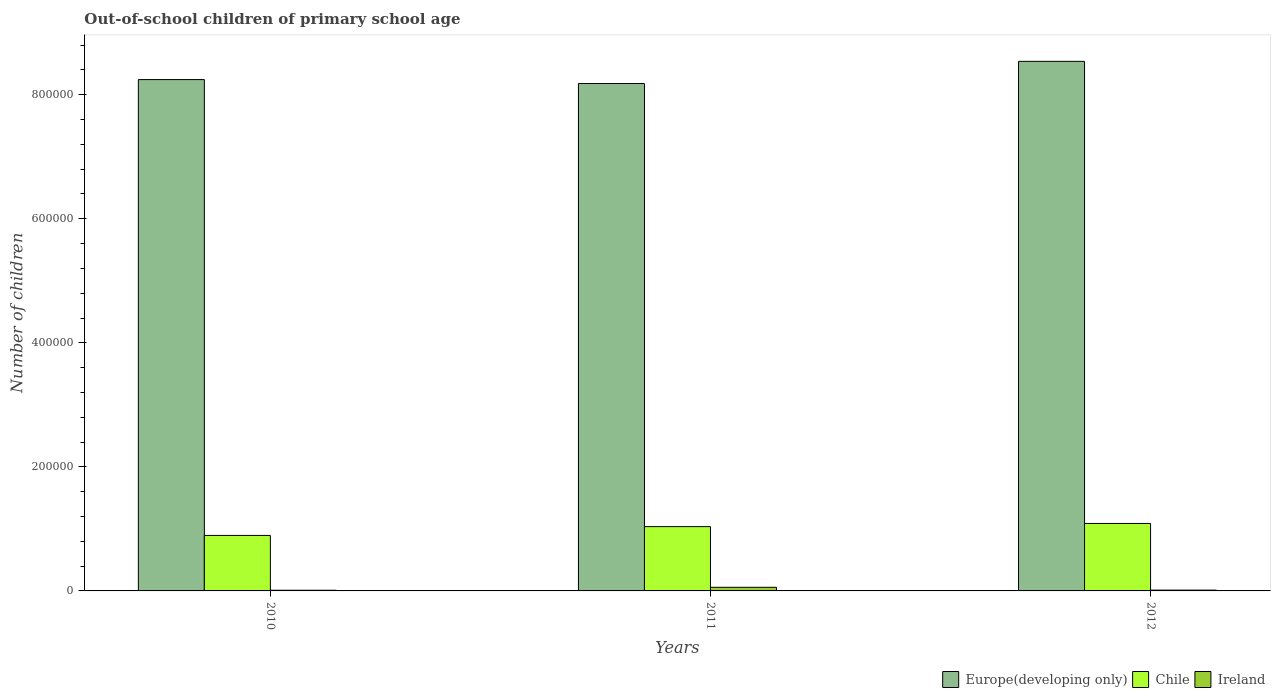How many groups of bars are there?
Make the answer very short. 3. Are the number of bars per tick equal to the number of legend labels?
Offer a very short reply. Yes. Are the number of bars on each tick of the X-axis equal?
Ensure brevity in your answer.  Yes. How many bars are there on the 3rd tick from the right?
Your answer should be compact. 3. What is the number of out-of-school children in Chile in 2012?
Provide a short and direct response. 1.09e+05. Across all years, what is the maximum number of out-of-school children in Europe(developing only)?
Give a very brief answer. 8.54e+05. Across all years, what is the minimum number of out-of-school children in Europe(developing only)?
Your answer should be compact. 8.18e+05. In which year was the number of out-of-school children in Chile maximum?
Give a very brief answer. 2012. What is the total number of out-of-school children in Ireland in the graph?
Your answer should be very brief. 8255. What is the difference between the number of out-of-school children in Chile in 2010 and that in 2011?
Make the answer very short. -1.42e+04. What is the difference between the number of out-of-school children in Chile in 2011 and the number of out-of-school children in Ireland in 2012?
Ensure brevity in your answer.  1.02e+05. What is the average number of out-of-school children in Chile per year?
Make the answer very short. 1.01e+05. In the year 2012, what is the difference between the number of out-of-school children in Europe(developing only) and number of out-of-school children in Ireland?
Give a very brief answer. 8.53e+05. What is the ratio of the number of out-of-school children in Ireland in 2011 to that in 2012?
Your response must be concise. 4.5. What is the difference between the highest and the second highest number of out-of-school children in Chile?
Your response must be concise. 5097. What is the difference between the highest and the lowest number of out-of-school children in Ireland?
Your answer should be very brief. 4752. Is the sum of the number of out-of-school children in Ireland in 2010 and 2011 greater than the maximum number of out-of-school children in Chile across all years?
Provide a short and direct response. No. What does the 1st bar from the left in 2012 represents?
Offer a very short reply. Europe(developing only). Is it the case that in every year, the sum of the number of out-of-school children in Ireland and number of out-of-school children in Europe(developing only) is greater than the number of out-of-school children in Chile?
Keep it short and to the point. Yes. How many years are there in the graph?
Keep it short and to the point. 3. What is the difference between two consecutive major ticks on the Y-axis?
Your answer should be very brief. 2.00e+05. How are the legend labels stacked?
Give a very brief answer. Horizontal. What is the title of the graph?
Your answer should be very brief. Out-of-school children of primary school age. Does "Norway" appear as one of the legend labels in the graph?
Your answer should be compact. No. What is the label or title of the Y-axis?
Your response must be concise. Number of children. What is the Number of children of Europe(developing only) in 2010?
Give a very brief answer. 8.24e+05. What is the Number of children in Chile in 2010?
Keep it short and to the point. 8.95e+04. What is the Number of children in Ireland in 2010?
Make the answer very short. 1101. What is the Number of children in Europe(developing only) in 2011?
Make the answer very short. 8.18e+05. What is the Number of children in Chile in 2011?
Your answer should be compact. 1.04e+05. What is the Number of children in Ireland in 2011?
Offer a terse response. 5853. What is the Number of children in Europe(developing only) in 2012?
Ensure brevity in your answer.  8.54e+05. What is the Number of children in Chile in 2012?
Ensure brevity in your answer.  1.09e+05. What is the Number of children in Ireland in 2012?
Ensure brevity in your answer.  1301. Across all years, what is the maximum Number of children of Europe(developing only)?
Ensure brevity in your answer.  8.54e+05. Across all years, what is the maximum Number of children of Chile?
Provide a succinct answer. 1.09e+05. Across all years, what is the maximum Number of children of Ireland?
Offer a terse response. 5853. Across all years, what is the minimum Number of children of Europe(developing only)?
Keep it short and to the point. 8.18e+05. Across all years, what is the minimum Number of children in Chile?
Make the answer very short. 8.95e+04. Across all years, what is the minimum Number of children of Ireland?
Your response must be concise. 1101. What is the total Number of children in Europe(developing only) in the graph?
Offer a terse response. 2.50e+06. What is the total Number of children in Chile in the graph?
Your answer should be compact. 3.02e+05. What is the total Number of children in Ireland in the graph?
Offer a terse response. 8255. What is the difference between the Number of children in Europe(developing only) in 2010 and that in 2011?
Keep it short and to the point. 6343. What is the difference between the Number of children in Chile in 2010 and that in 2011?
Provide a succinct answer. -1.42e+04. What is the difference between the Number of children of Ireland in 2010 and that in 2011?
Make the answer very short. -4752. What is the difference between the Number of children of Europe(developing only) in 2010 and that in 2012?
Your response must be concise. -2.94e+04. What is the difference between the Number of children of Chile in 2010 and that in 2012?
Provide a succinct answer. -1.93e+04. What is the difference between the Number of children in Ireland in 2010 and that in 2012?
Provide a short and direct response. -200. What is the difference between the Number of children of Europe(developing only) in 2011 and that in 2012?
Make the answer very short. -3.57e+04. What is the difference between the Number of children of Chile in 2011 and that in 2012?
Your answer should be compact. -5097. What is the difference between the Number of children of Ireland in 2011 and that in 2012?
Give a very brief answer. 4552. What is the difference between the Number of children of Europe(developing only) in 2010 and the Number of children of Chile in 2011?
Make the answer very short. 7.21e+05. What is the difference between the Number of children of Europe(developing only) in 2010 and the Number of children of Ireland in 2011?
Offer a very short reply. 8.19e+05. What is the difference between the Number of children of Chile in 2010 and the Number of children of Ireland in 2011?
Your answer should be very brief. 8.36e+04. What is the difference between the Number of children of Europe(developing only) in 2010 and the Number of children of Chile in 2012?
Offer a very short reply. 7.16e+05. What is the difference between the Number of children of Europe(developing only) in 2010 and the Number of children of Ireland in 2012?
Your answer should be very brief. 8.23e+05. What is the difference between the Number of children in Chile in 2010 and the Number of children in Ireland in 2012?
Provide a short and direct response. 8.82e+04. What is the difference between the Number of children of Europe(developing only) in 2011 and the Number of children of Chile in 2012?
Offer a very short reply. 7.09e+05. What is the difference between the Number of children of Europe(developing only) in 2011 and the Number of children of Ireland in 2012?
Ensure brevity in your answer.  8.17e+05. What is the difference between the Number of children in Chile in 2011 and the Number of children in Ireland in 2012?
Provide a succinct answer. 1.02e+05. What is the average Number of children of Europe(developing only) per year?
Give a very brief answer. 8.32e+05. What is the average Number of children in Chile per year?
Offer a terse response. 1.01e+05. What is the average Number of children in Ireland per year?
Provide a short and direct response. 2751.67. In the year 2010, what is the difference between the Number of children of Europe(developing only) and Number of children of Chile?
Your answer should be compact. 7.35e+05. In the year 2010, what is the difference between the Number of children of Europe(developing only) and Number of children of Ireland?
Provide a short and direct response. 8.23e+05. In the year 2010, what is the difference between the Number of children in Chile and Number of children in Ireland?
Your answer should be compact. 8.84e+04. In the year 2011, what is the difference between the Number of children in Europe(developing only) and Number of children in Chile?
Make the answer very short. 7.14e+05. In the year 2011, what is the difference between the Number of children in Europe(developing only) and Number of children in Ireland?
Provide a short and direct response. 8.12e+05. In the year 2011, what is the difference between the Number of children of Chile and Number of children of Ireland?
Offer a very short reply. 9.78e+04. In the year 2012, what is the difference between the Number of children in Europe(developing only) and Number of children in Chile?
Give a very brief answer. 7.45e+05. In the year 2012, what is the difference between the Number of children in Europe(developing only) and Number of children in Ireland?
Your answer should be compact. 8.53e+05. In the year 2012, what is the difference between the Number of children of Chile and Number of children of Ireland?
Provide a short and direct response. 1.07e+05. What is the ratio of the Number of children in Chile in 2010 to that in 2011?
Offer a terse response. 0.86. What is the ratio of the Number of children in Ireland in 2010 to that in 2011?
Your answer should be compact. 0.19. What is the ratio of the Number of children of Europe(developing only) in 2010 to that in 2012?
Ensure brevity in your answer.  0.97. What is the ratio of the Number of children in Chile in 2010 to that in 2012?
Keep it short and to the point. 0.82. What is the ratio of the Number of children in Ireland in 2010 to that in 2012?
Your answer should be very brief. 0.85. What is the ratio of the Number of children in Europe(developing only) in 2011 to that in 2012?
Give a very brief answer. 0.96. What is the ratio of the Number of children in Chile in 2011 to that in 2012?
Ensure brevity in your answer.  0.95. What is the ratio of the Number of children in Ireland in 2011 to that in 2012?
Make the answer very short. 4.5. What is the difference between the highest and the second highest Number of children of Europe(developing only)?
Ensure brevity in your answer.  2.94e+04. What is the difference between the highest and the second highest Number of children of Chile?
Give a very brief answer. 5097. What is the difference between the highest and the second highest Number of children in Ireland?
Your response must be concise. 4552. What is the difference between the highest and the lowest Number of children in Europe(developing only)?
Ensure brevity in your answer.  3.57e+04. What is the difference between the highest and the lowest Number of children of Chile?
Provide a short and direct response. 1.93e+04. What is the difference between the highest and the lowest Number of children in Ireland?
Provide a short and direct response. 4752. 